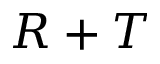Convert formula to latex. <formula><loc_0><loc_0><loc_500><loc_500>R + T</formula> 